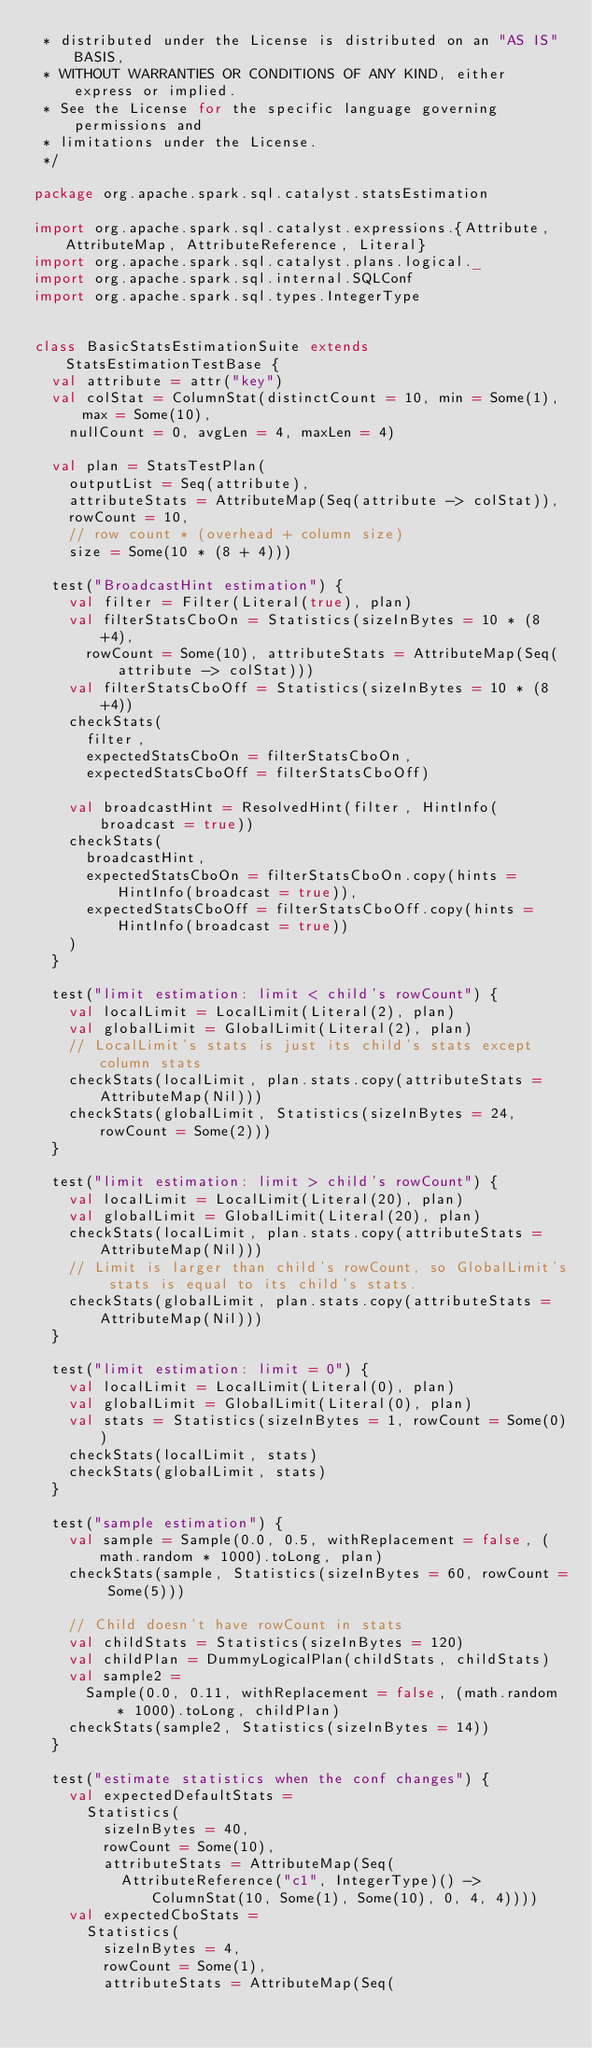<code> <loc_0><loc_0><loc_500><loc_500><_Scala_> * distributed under the License is distributed on an "AS IS" BASIS,
 * WITHOUT WARRANTIES OR CONDITIONS OF ANY KIND, either express or implied.
 * See the License for the specific language governing permissions and
 * limitations under the License.
 */

package org.apache.spark.sql.catalyst.statsEstimation

import org.apache.spark.sql.catalyst.expressions.{Attribute, AttributeMap, AttributeReference, Literal}
import org.apache.spark.sql.catalyst.plans.logical._
import org.apache.spark.sql.internal.SQLConf
import org.apache.spark.sql.types.IntegerType


class BasicStatsEstimationSuite extends StatsEstimationTestBase {
  val attribute = attr("key")
  val colStat = ColumnStat(distinctCount = 10, min = Some(1), max = Some(10),
    nullCount = 0, avgLen = 4, maxLen = 4)

  val plan = StatsTestPlan(
    outputList = Seq(attribute),
    attributeStats = AttributeMap(Seq(attribute -> colStat)),
    rowCount = 10,
    // row count * (overhead + column size)
    size = Some(10 * (8 + 4)))

  test("BroadcastHint estimation") {
    val filter = Filter(Literal(true), plan)
    val filterStatsCboOn = Statistics(sizeInBytes = 10 * (8 +4),
      rowCount = Some(10), attributeStats = AttributeMap(Seq(attribute -> colStat)))
    val filterStatsCboOff = Statistics(sizeInBytes = 10 * (8 +4))
    checkStats(
      filter,
      expectedStatsCboOn = filterStatsCboOn,
      expectedStatsCboOff = filterStatsCboOff)

    val broadcastHint = ResolvedHint(filter, HintInfo(broadcast = true))
    checkStats(
      broadcastHint,
      expectedStatsCboOn = filterStatsCboOn.copy(hints = HintInfo(broadcast = true)),
      expectedStatsCboOff = filterStatsCboOff.copy(hints = HintInfo(broadcast = true))
    )
  }

  test("limit estimation: limit < child's rowCount") {
    val localLimit = LocalLimit(Literal(2), plan)
    val globalLimit = GlobalLimit(Literal(2), plan)
    // LocalLimit's stats is just its child's stats except column stats
    checkStats(localLimit, plan.stats.copy(attributeStats = AttributeMap(Nil)))
    checkStats(globalLimit, Statistics(sizeInBytes = 24, rowCount = Some(2)))
  }

  test("limit estimation: limit > child's rowCount") {
    val localLimit = LocalLimit(Literal(20), plan)
    val globalLimit = GlobalLimit(Literal(20), plan)
    checkStats(localLimit, plan.stats.copy(attributeStats = AttributeMap(Nil)))
    // Limit is larger than child's rowCount, so GlobalLimit's stats is equal to its child's stats.
    checkStats(globalLimit, plan.stats.copy(attributeStats = AttributeMap(Nil)))
  }

  test("limit estimation: limit = 0") {
    val localLimit = LocalLimit(Literal(0), plan)
    val globalLimit = GlobalLimit(Literal(0), plan)
    val stats = Statistics(sizeInBytes = 1, rowCount = Some(0))
    checkStats(localLimit, stats)
    checkStats(globalLimit, stats)
  }

  test("sample estimation") {
    val sample = Sample(0.0, 0.5, withReplacement = false, (math.random * 1000).toLong, plan)
    checkStats(sample, Statistics(sizeInBytes = 60, rowCount = Some(5)))

    // Child doesn't have rowCount in stats
    val childStats = Statistics(sizeInBytes = 120)
    val childPlan = DummyLogicalPlan(childStats, childStats)
    val sample2 =
      Sample(0.0, 0.11, withReplacement = false, (math.random * 1000).toLong, childPlan)
    checkStats(sample2, Statistics(sizeInBytes = 14))
  }

  test("estimate statistics when the conf changes") {
    val expectedDefaultStats =
      Statistics(
        sizeInBytes = 40,
        rowCount = Some(10),
        attributeStats = AttributeMap(Seq(
          AttributeReference("c1", IntegerType)() -> ColumnStat(10, Some(1), Some(10), 0, 4, 4))))
    val expectedCboStats =
      Statistics(
        sizeInBytes = 4,
        rowCount = Some(1),
        attributeStats = AttributeMap(Seq(</code> 